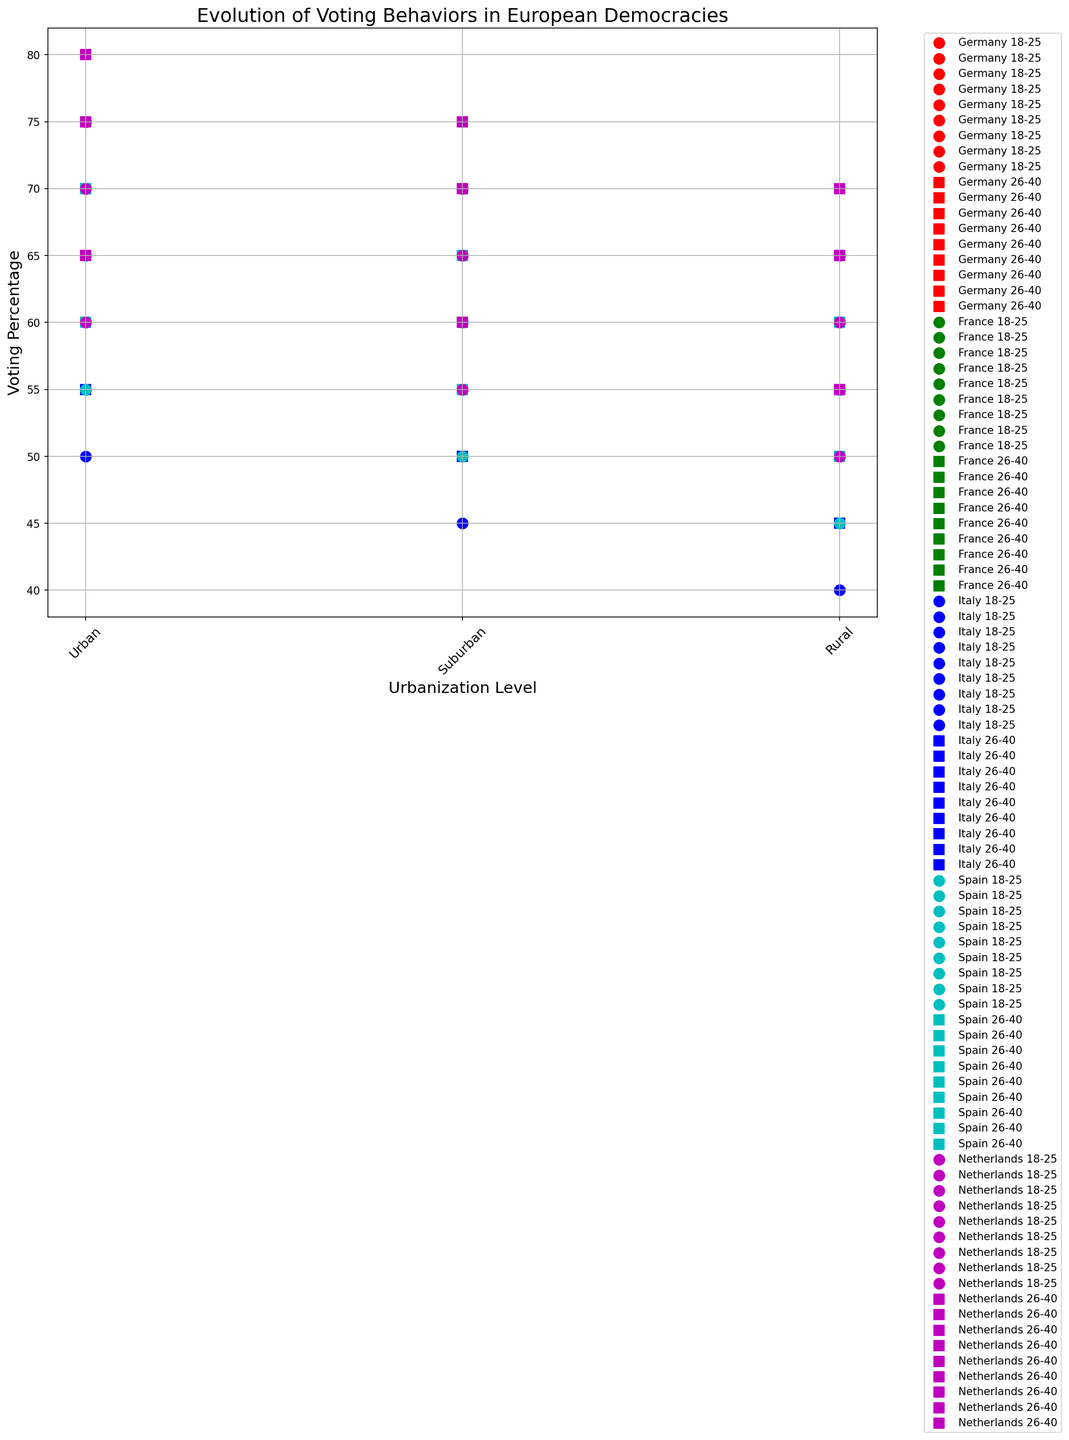What is the average voting percentage for 18-25 age group with Master education in urban areas across all countries? To find the average, sum the voting percentages for the 18-25 age group with Master education in urban areas across Germany (75), France (70), Italy (65), Spain (70), and the Netherlands (75). Then divide by the number of countries: (75 + 70 + 65 + 70 + 75) / 5.
Answer: 71 Which country has the highest voting percentage for the 26-40 age group with Master education in urban areas? Look at the data points for the 26-40 age group with Master education in urban areas across all countries, and identify the highest value. Germany, France, and the Netherlands have 80, while Italy and Spain have 75. The highest voting percentage is thus 80 in Germany, France, and the Netherlands.
Answer: Germany, France, Netherlands (tie) Is the voting percentage for 26-40 age group with High School education in suburban areas higher in Germany or France? Compare the voting percentages for the 26-40 age group with High School education in suburban areas in Germany (60) and France (55). Since 60 > 55, Germany has the higher voting percentage.
Answer: Germany What is the total voting percentage for the 18-25 and 26-40 age groups with Bachelor education in rural areas in Italy? Add the voting percentages for the 18-25 and 26-40 age groups with Bachelor education in rural areas in Italy: 50 (18-25) + 55 (26-40).
Answer: 105 How does the voting percentage for the 18-25 age group with High School education in rural areas compare between Spain and the Netherlands? Compare the voting percentages for the 18-25 age group with High School education in rural areas between Spain (45) and the Netherlands (50). The Netherlands has a higher voting percentage than Spain.
Answer: Netherlands Which age group and education level has the lowest voting percentage in any rural area in Italy? Examine all the voting percentages for rural areas in Italy, and find the minimum value. The lowest values are 40 for the 18-25 age group with High School education.
Answer: 18-25, High School What is the difference in voting percentage between urban and rural areas for the 26-40 age group with Master education in Spain? Subtract the voting percentage in rural areas from that in urban areas for the 26-40 age group with Master education in Spain: 75 (urban) - 65 (rural).
Answer: 10 Does Germany or France have a higher average voting percentage for the 18-25 age group across all education levels in urban areas? Calculate the average for Germany and France: For Germany: (60 + 70 + 75) / 3 = 68.33. For France: (55 + 65 + 70) / 3 = 63.33. Compare the averages, Germany has a higher average.
Answer: Germany 